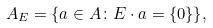<formula> <loc_0><loc_0><loc_500><loc_500>A _ { E } = \{ a \in A \colon E \cdot a = \{ 0 \} \} ,</formula> 